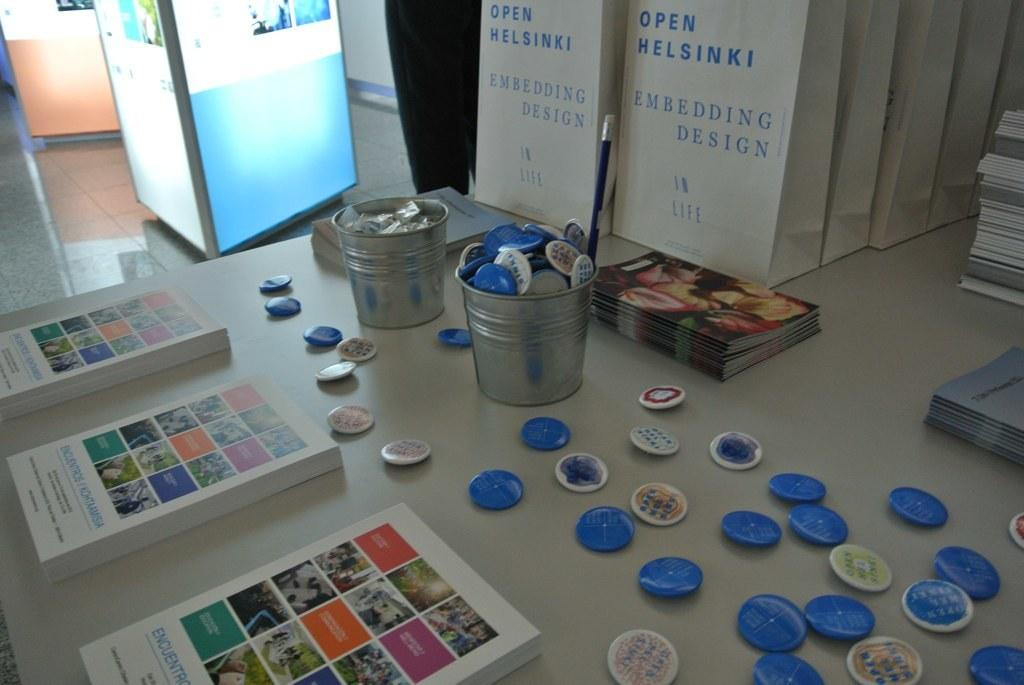Provide a one-sentence caption for the provided image. Open Helsinki white bags with buttons and brochures on the table. 